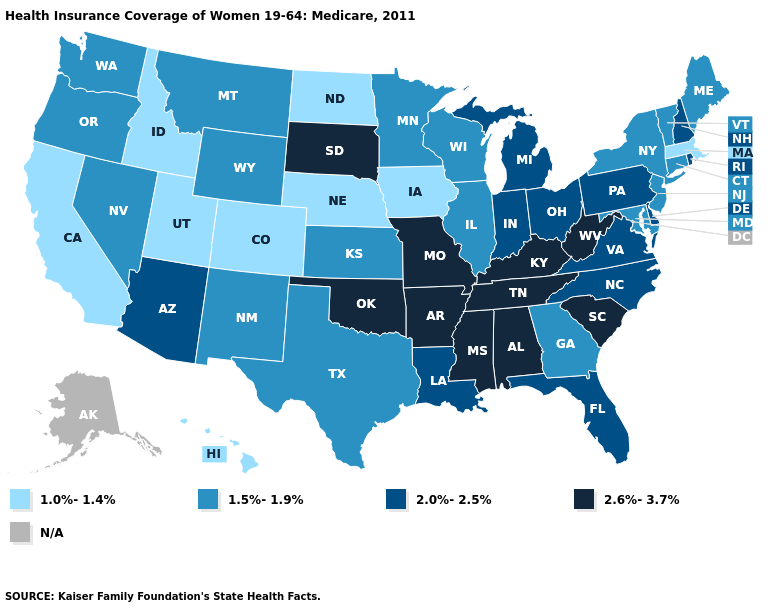What is the value of Arkansas?
Write a very short answer. 2.6%-3.7%. Which states hav the highest value in the South?
Quick response, please. Alabama, Arkansas, Kentucky, Mississippi, Oklahoma, South Carolina, Tennessee, West Virginia. What is the lowest value in states that border Wisconsin?
Keep it brief. 1.0%-1.4%. What is the value of South Carolina?
Concise answer only. 2.6%-3.7%. What is the highest value in states that border Delaware?
Short answer required. 2.0%-2.5%. What is the value of Vermont?
Keep it brief. 1.5%-1.9%. How many symbols are there in the legend?
Be succinct. 5. Does West Virginia have the highest value in the USA?
Answer briefly. Yes. What is the highest value in states that border Wyoming?
Write a very short answer. 2.6%-3.7%. What is the highest value in the Northeast ?
Short answer required. 2.0%-2.5%. What is the lowest value in states that border Alabama?
Be succinct. 1.5%-1.9%. What is the value of Colorado?
Be succinct. 1.0%-1.4%. Among the states that border Colorado , does Oklahoma have the highest value?
Give a very brief answer. Yes. Which states have the lowest value in the USA?
Quick response, please. California, Colorado, Hawaii, Idaho, Iowa, Massachusetts, Nebraska, North Dakota, Utah. 